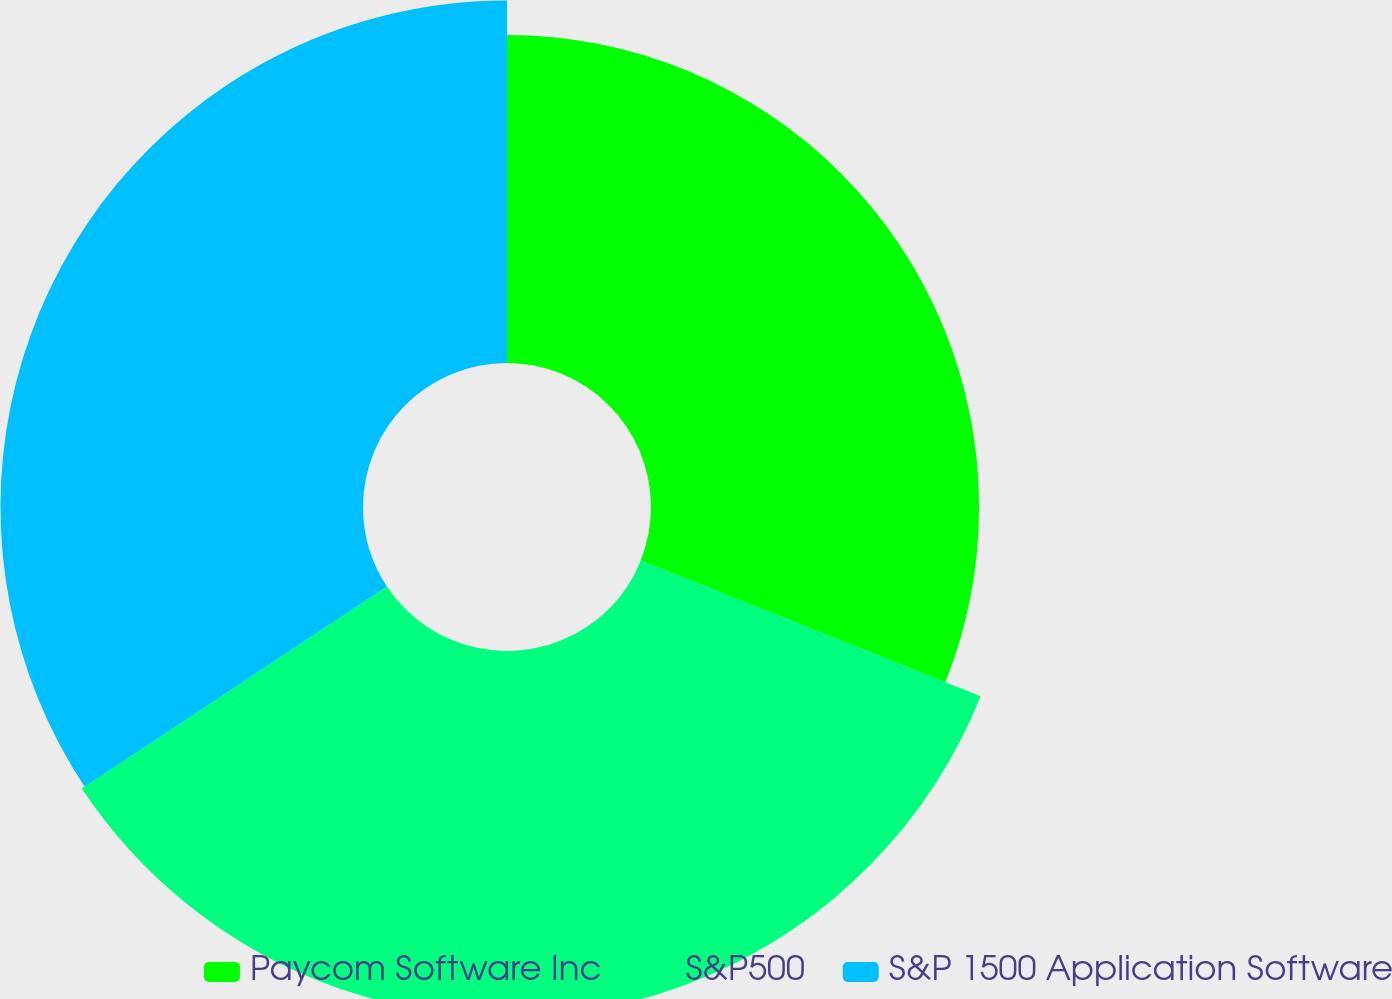Convert chart to OTSL. <chart><loc_0><loc_0><loc_500><loc_500><pie_chart><fcel>Paycom Software Inc<fcel>S&P500<fcel>S&P 1500 Application Software<nl><fcel>31.05%<fcel>34.64%<fcel>34.31%<nl></chart> 